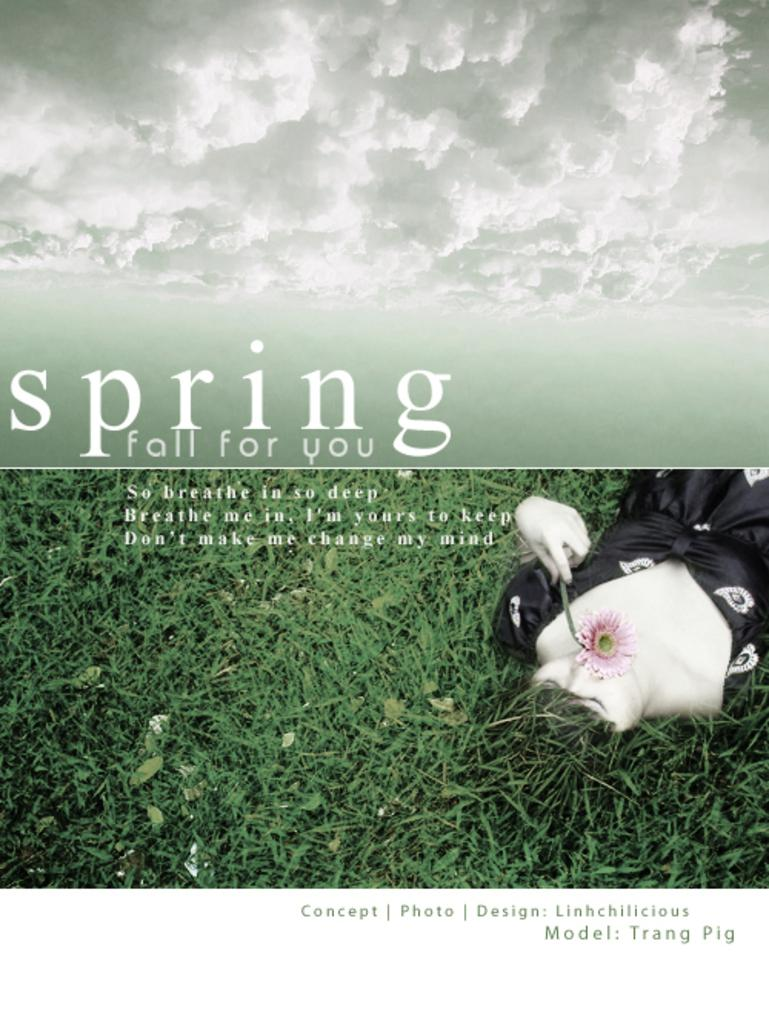Who is present in the image? There is a woman in the image. What is the woman wearing? The woman is wearing clothes. What is the woman doing in the image? The woman is lying down. What is the woman holding in her hand? The woman is holding a flower in her hand. What type of vegetation can be seen in the image? There is grass in the image. What else can be seen in the image besides the woman and the grass? There is text in the image. How would you describe the weather in the image? The sky is cloudy in the image. How many fingers does the woman have on her left hand in the image? The image does not show the woman's fingers, so it is not possible to determine the number of fingers on her left hand. 